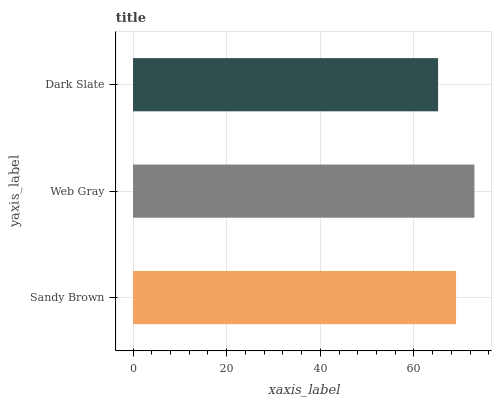Is Dark Slate the minimum?
Answer yes or no. Yes. Is Web Gray the maximum?
Answer yes or no. Yes. Is Web Gray the minimum?
Answer yes or no. No. Is Dark Slate the maximum?
Answer yes or no. No. Is Web Gray greater than Dark Slate?
Answer yes or no. Yes. Is Dark Slate less than Web Gray?
Answer yes or no. Yes. Is Dark Slate greater than Web Gray?
Answer yes or no. No. Is Web Gray less than Dark Slate?
Answer yes or no. No. Is Sandy Brown the high median?
Answer yes or no. Yes. Is Sandy Brown the low median?
Answer yes or no. Yes. Is Dark Slate the high median?
Answer yes or no. No. Is Dark Slate the low median?
Answer yes or no. No. 